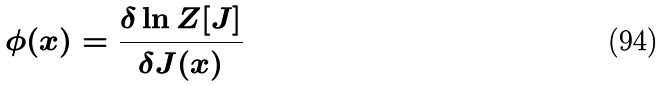<formula> <loc_0><loc_0><loc_500><loc_500>\phi ( x ) = \frac { \delta \ln Z [ J ] } { \delta J ( x ) }</formula> 